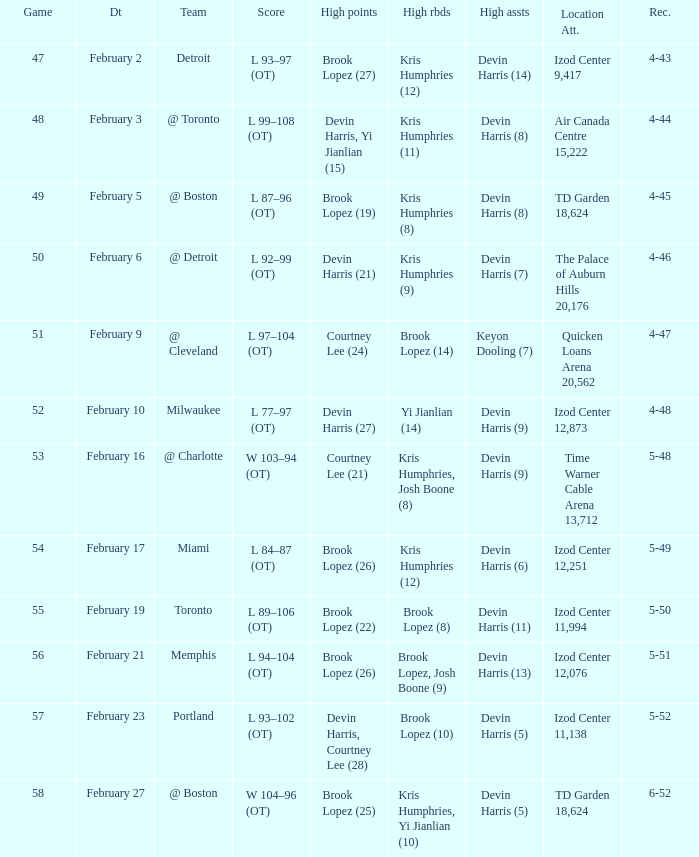What was the record in the game against Memphis? 5-51. 